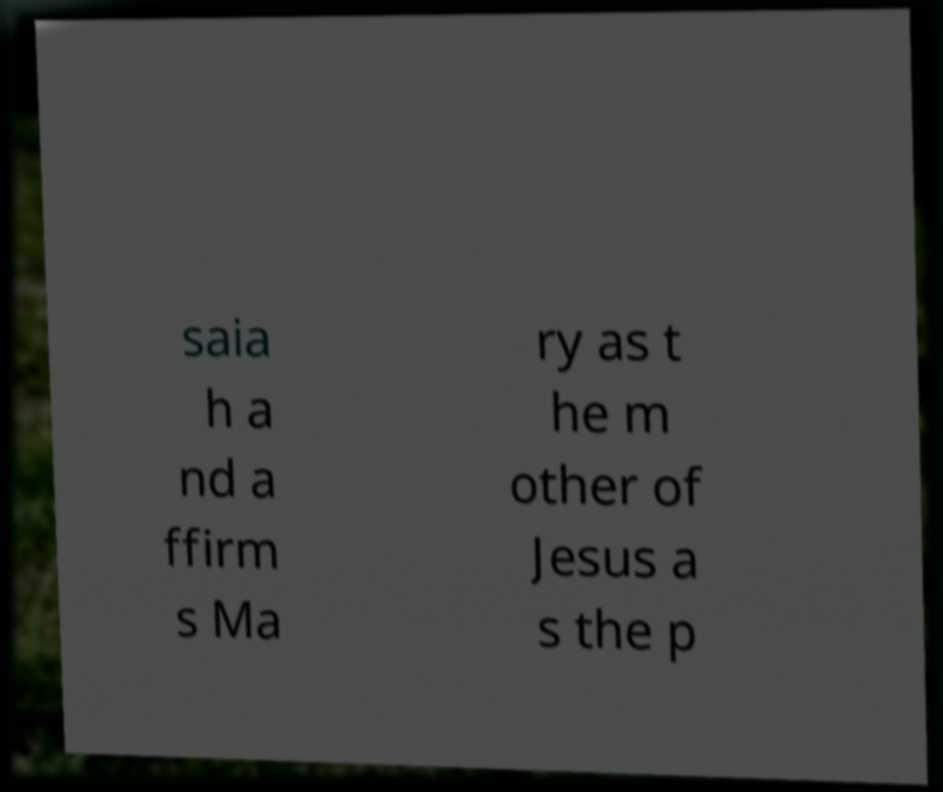Please read and relay the text visible in this image. What does it say? saia h a nd a ffirm s Ma ry as t he m other of Jesus a s the p 